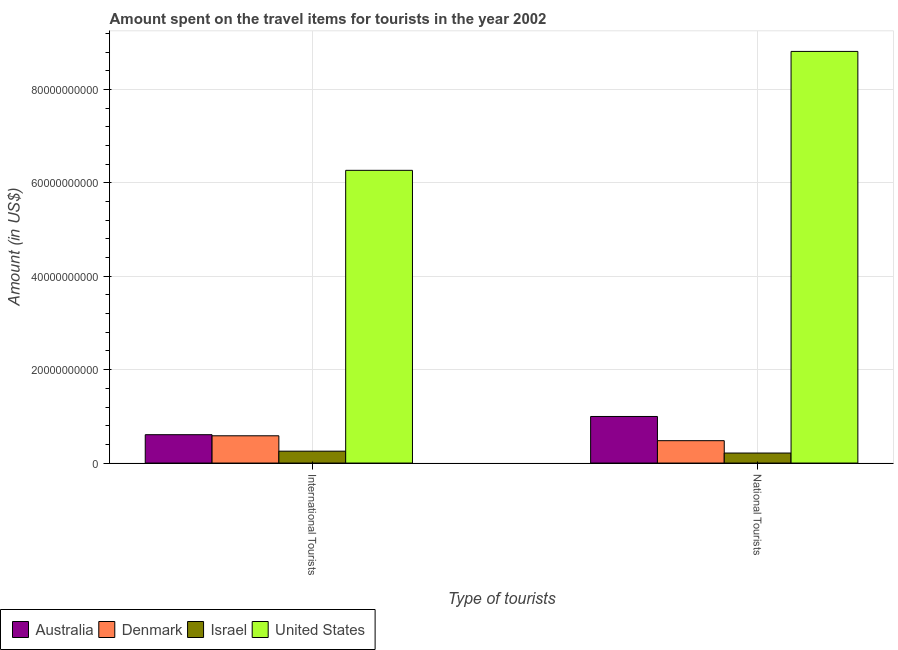Are the number of bars per tick equal to the number of legend labels?
Provide a short and direct response. Yes. How many bars are there on the 2nd tick from the left?
Your answer should be very brief. 4. How many bars are there on the 2nd tick from the right?
Make the answer very short. 4. What is the label of the 1st group of bars from the left?
Your answer should be very brief. International Tourists. What is the amount spent on travel items of international tourists in Israel?
Give a very brief answer. 2.54e+09. Across all countries, what is the maximum amount spent on travel items of international tourists?
Offer a very short reply. 6.27e+1. Across all countries, what is the minimum amount spent on travel items of international tourists?
Provide a short and direct response. 2.54e+09. In which country was the amount spent on travel items of national tourists maximum?
Your answer should be very brief. United States. What is the total amount spent on travel items of national tourists in the graph?
Offer a very short reply. 1.05e+11. What is the difference between the amount spent on travel items of international tourists in Denmark and that in United States?
Your answer should be compact. -5.68e+1. What is the difference between the amount spent on travel items of international tourists in Denmark and the amount spent on travel items of national tourists in Australia?
Make the answer very short. -4.13e+09. What is the average amount spent on travel items of international tourists per country?
Offer a terse response. 1.93e+1. What is the difference between the amount spent on travel items of national tourists and amount spent on travel items of international tourists in Israel?
Provide a short and direct response. -3.98e+08. In how many countries, is the amount spent on travel items of international tourists greater than 88000000000 US$?
Make the answer very short. 0. What is the ratio of the amount spent on travel items of international tourists in Denmark to that in United States?
Your response must be concise. 0.09. What does the 4th bar from the left in International Tourists represents?
Offer a very short reply. United States. What does the 2nd bar from the right in International Tourists represents?
Give a very brief answer. Israel. How many bars are there?
Offer a very short reply. 8. Are all the bars in the graph horizontal?
Offer a very short reply. No. What is the difference between two consecutive major ticks on the Y-axis?
Make the answer very short. 2.00e+1. Are the values on the major ticks of Y-axis written in scientific E-notation?
Your answer should be compact. No. Does the graph contain any zero values?
Provide a short and direct response. No. What is the title of the graph?
Provide a succinct answer. Amount spent on the travel items for tourists in the year 2002. Does "Congo (Republic)" appear as one of the legend labels in the graph?
Provide a short and direct response. No. What is the label or title of the X-axis?
Provide a succinct answer. Type of tourists. What is the Amount (in US$) in Australia in International Tourists?
Provide a succinct answer. 6.07e+09. What is the Amount (in US$) in Denmark in International Tourists?
Ensure brevity in your answer.  5.84e+09. What is the Amount (in US$) of Israel in International Tourists?
Provide a short and direct response. 2.54e+09. What is the Amount (in US$) of United States in International Tourists?
Offer a very short reply. 6.27e+1. What is the Amount (in US$) of Australia in National Tourists?
Provide a short and direct response. 9.97e+09. What is the Amount (in US$) of Denmark in National Tourists?
Provide a succinct answer. 4.79e+09. What is the Amount (in US$) of Israel in National Tourists?
Ensure brevity in your answer.  2.14e+09. What is the Amount (in US$) of United States in National Tourists?
Ensure brevity in your answer.  8.81e+1. Across all Type of tourists, what is the maximum Amount (in US$) in Australia?
Your answer should be very brief. 9.97e+09. Across all Type of tourists, what is the maximum Amount (in US$) in Denmark?
Ensure brevity in your answer.  5.84e+09. Across all Type of tourists, what is the maximum Amount (in US$) of Israel?
Keep it short and to the point. 2.54e+09. Across all Type of tourists, what is the maximum Amount (in US$) in United States?
Keep it short and to the point. 8.81e+1. Across all Type of tourists, what is the minimum Amount (in US$) in Australia?
Offer a terse response. 6.07e+09. Across all Type of tourists, what is the minimum Amount (in US$) of Denmark?
Ensure brevity in your answer.  4.79e+09. Across all Type of tourists, what is the minimum Amount (in US$) in Israel?
Provide a short and direct response. 2.14e+09. Across all Type of tourists, what is the minimum Amount (in US$) in United States?
Make the answer very short. 6.27e+1. What is the total Amount (in US$) of Australia in the graph?
Offer a terse response. 1.60e+1. What is the total Amount (in US$) in Denmark in the graph?
Make the answer very short. 1.06e+1. What is the total Amount (in US$) in Israel in the graph?
Provide a short and direct response. 4.69e+09. What is the total Amount (in US$) of United States in the graph?
Offer a terse response. 1.51e+11. What is the difference between the Amount (in US$) of Australia in International Tourists and that in National Tourists?
Make the answer very short. -3.90e+09. What is the difference between the Amount (in US$) of Denmark in International Tourists and that in National Tourists?
Keep it short and to the point. 1.05e+09. What is the difference between the Amount (in US$) of Israel in International Tourists and that in National Tourists?
Your answer should be very brief. 3.98e+08. What is the difference between the Amount (in US$) in United States in International Tourists and that in National Tourists?
Make the answer very short. -2.55e+1. What is the difference between the Amount (in US$) in Australia in International Tourists and the Amount (in US$) in Denmark in National Tourists?
Ensure brevity in your answer.  1.28e+09. What is the difference between the Amount (in US$) of Australia in International Tourists and the Amount (in US$) of Israel in National Tourists?
Your answer should be compact. 3.93e+09. What is the difference between the Amount (in US$) of Australia in International Tourists and the Amount (in US$) of United States in National Tourists?
Keep it short and to the point. -8.21e+1. What is the difference between the Amount (in US$) in Denmark in International Tourists and the Amount (in US$) in Israel in National Tourists?
Your answer should be compact. 3.69e+09. What is the difference between the Amount (in US$) in Denmark in International Tourists and the Amount (in US$) in United States in National Tourists?
Offer a terse response. -8.23e+1. What is the difference between the Amount (in US$) of Israel in International Tourists and the Amount (in US$) of United States in National Tourists?
Give a very brief answer. -8.56e+1. What is the average Amount (in US$) in Australia per Type of tourists?
Make the answer very short. 8.02e+09. What is the average Amount (in US$) of Denmark per Type of tourists?
Make the answer very short. 5.31e+09. What is the average Amount (in US$) of Israel per Type of tourists?
Offer a very short reply. 2.34e+09. What is the average Amount (in US$) in United States per Type of tourists?
Make the answer very short. 7.54e+1. What is the difference between the Amount (in US$) in Australia and Amount (in US$) in Denmark in International Tourists?
Offer a very short reply. 2.34e+08. What is the difference between the Amount (in US$) in Australia and Amount (in US$) in Israel in International Tourists?
Your response must be concise. 3.53e+09. What is the difference between the Amount (in US$) in Australia and Amount (in US$) in United States in International Tourists?
Your answer should be very brief. -5.66e+1. What is the difference between the Amount (in US$) of Denmark and Amount (in US$) of Israel in International Tourists?
Give a very brief answer. 3.30e+09. What is the difference between the Amount (in US$) of Denmark and Amount (in US$) of United States in International Tourists?
Provide a succinct answer. -5.68e+1. What is the difference between the Amount (in US$) in Israel and Amount (in US$) in United States in International Tourists?
Keep it short and to the point. -6.01e+1. What is the difference between the Amount (in US$) in Australia and Amount (in US$) in Denmark in National Tourists?
Offer a very short reply. 5.18e+09. What is the difference between the Amount (in US$) in Australia and Amount (in US$) in Israel in National Tourists?
Offer a terse response. 7.83e+09. What is the difference between the Amount (in US$) in Australia and Amount (in US$) in United States in National Tourists?
Give a very brief answer. -7.82e+1. What is the difference between the Amount (in US$) in Denmark and Amount (in US$) in Israel in National Tourists?
Ensure brevity in your answer.  2.65e+09. What is the difference between the Amount (in US$) in Denmark and Amount (in US$) in United States in National Tourists?
Ensure brevity in your answer.  -8.33e+1. What is the difference between the Amount (in US$) of Israel and Amount (in US$) of United States in National Tourists?
Offer a terse response. -8.60e+1. What is the ratio of the Amount (in US$) of Australia in International Tourists to that in National Tourists?
Offer a terse response. 0.61. What is the ratio of the Amount (in US$) of Denmark in International Tourists to that in National Tourists?
Your answer should be very brief. 1.22. What is the ratio of the Amount (in US$) of Israel in International Tourists to that in National Tourists?
Make the answer very short. 1.19. What is the ratio of the Amount (in US$) in United States in International Tourists to that in National Tourists?
Offer a terse response. 0.71. What is the difference between the highest and the second highest Amount (in US$) of Australia?
Offer a very short reply. 3.90e+09. What is the difference between the highest and the second highest Amount (in US$) of Denmark?
Your response must be concise. 1.05e+09. What is the difference between the highest and the second highest Amount (in US$) in Israel?
Offer a terse response. 3.98e+08. What is the difference between the highest and the second highest Amount (in US$) in United States?
Your response must be concise. 2.55e+1. What is the difference between the highest and the lowest Amount (in US$) in Australia?
Your response must be concise. 3.90e+09. What is the difference between the highest and the lowest Amount (in US$) in Denmark?
Provide a succinct answer. 1.05e+09. What is the difference between the highest and the lowest Amount (in US$) in Israel?
Give a very brief answer. 3.98e+08. What is the difference between the highest and the lowest Amount (in US$) in United States?
Provide a succinct answer. 2.55e+1. 